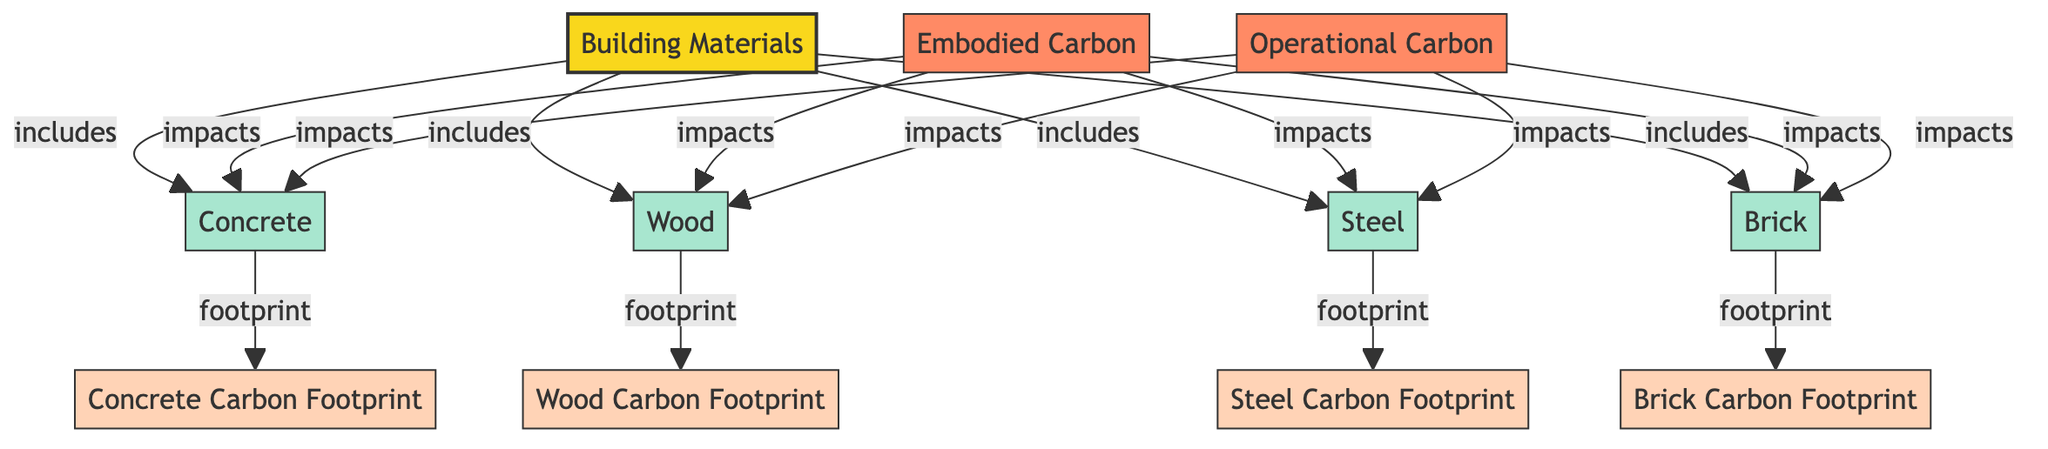What are the four types of building materials included in the diagram? The diagram shows four building materials as nodes connected to the main node, labeled Concrete, Wood, Steel, and Brick.
Answer: Concrete, Wood, Steel, Brick How many carbon footprint details are specified in the diagram? There are four carbon footprint details, one for each material, indicated as separate nodes: Concrete Carbon Footprint, Wood Carbon Footprint, Steel Carbon Footprint, and Brick Carbon Footprint.
Answer: Four Which building material has a footprint node directly linked to it? The diagram shows that each building material node (Concrete, Wood, Steel, Brick) has a footprint node associated with it, indicating a direct link. All of them are connected to their respective carbon footprint nodes.
Answer: All What impacts are associated with embodied carbon? The embodied carbon impacts all four building materials: Concrete, Wood, Steel, and Brick are all linked to the embodied carbon impact node, indicating that they contribute to it.
Answer: Concrete, Wood, Steel, Brick Which building material corresponds to the carbon footprint of steel? The diagram explicitly links Steel to its respective carbon footprint detail node, called Steel Carbon Footprint, making it straightforward to identify.
Answer: Steel Carbon Footprint How many nodes are there in total in the diagram? Counting the nodes listed, there are a total of eleven nodes: one main node, four building material nodes, two impact nodes, and four carbon footprint detail nodes, resulting in an overall total of eleven.
Answer: Eleven What is the relationship between operational carbon and building materials? Operational carbon impacts all four building materials as depicted by the direct links from the operational carbon node to each material node in the diagram.
Answer: Impacts all materials Which carbon footprint type is associated with wood? The carbon footprint type associated with Wood is labeled Wood Carbon Footprint, which is a detail node connected directly to the Wood node.
Answer: Wood Carbon Footprint 